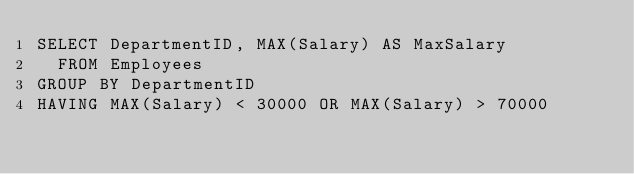Convert code to text. <code><loc_0><loc_0><loc_500><loc_500><_SQL_>SELECT DepartmentID, MAX(Salary) AS MaxSalary
  FROM Employees
GROUP BY DepartmentID
HAVING MAX(Salary) < 30000 OR MAX(Salary) > 70000</code> 